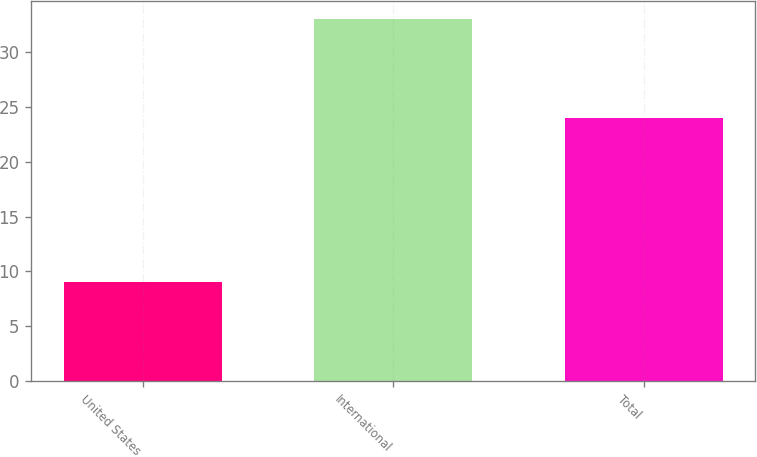Convert chart. <chart><loc_0><loc_0><loc_500><loc_500><bar_chart><fcel>United States<fcel>International<fcel>Total<nl><fcel>9<fcel>33<fcel>24<nl></chart> 